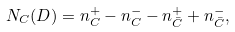Convert formula to latex. <formula><loc_0><loc_0><loc_500><loc_500>N _ { C } ( D ) = n _ { C } ^ { + } - n _ { C } ^ { - } - n _ { \bar { C } } ^ { + } + n _ { \bar { C } } ^ { - } ,</formula> 